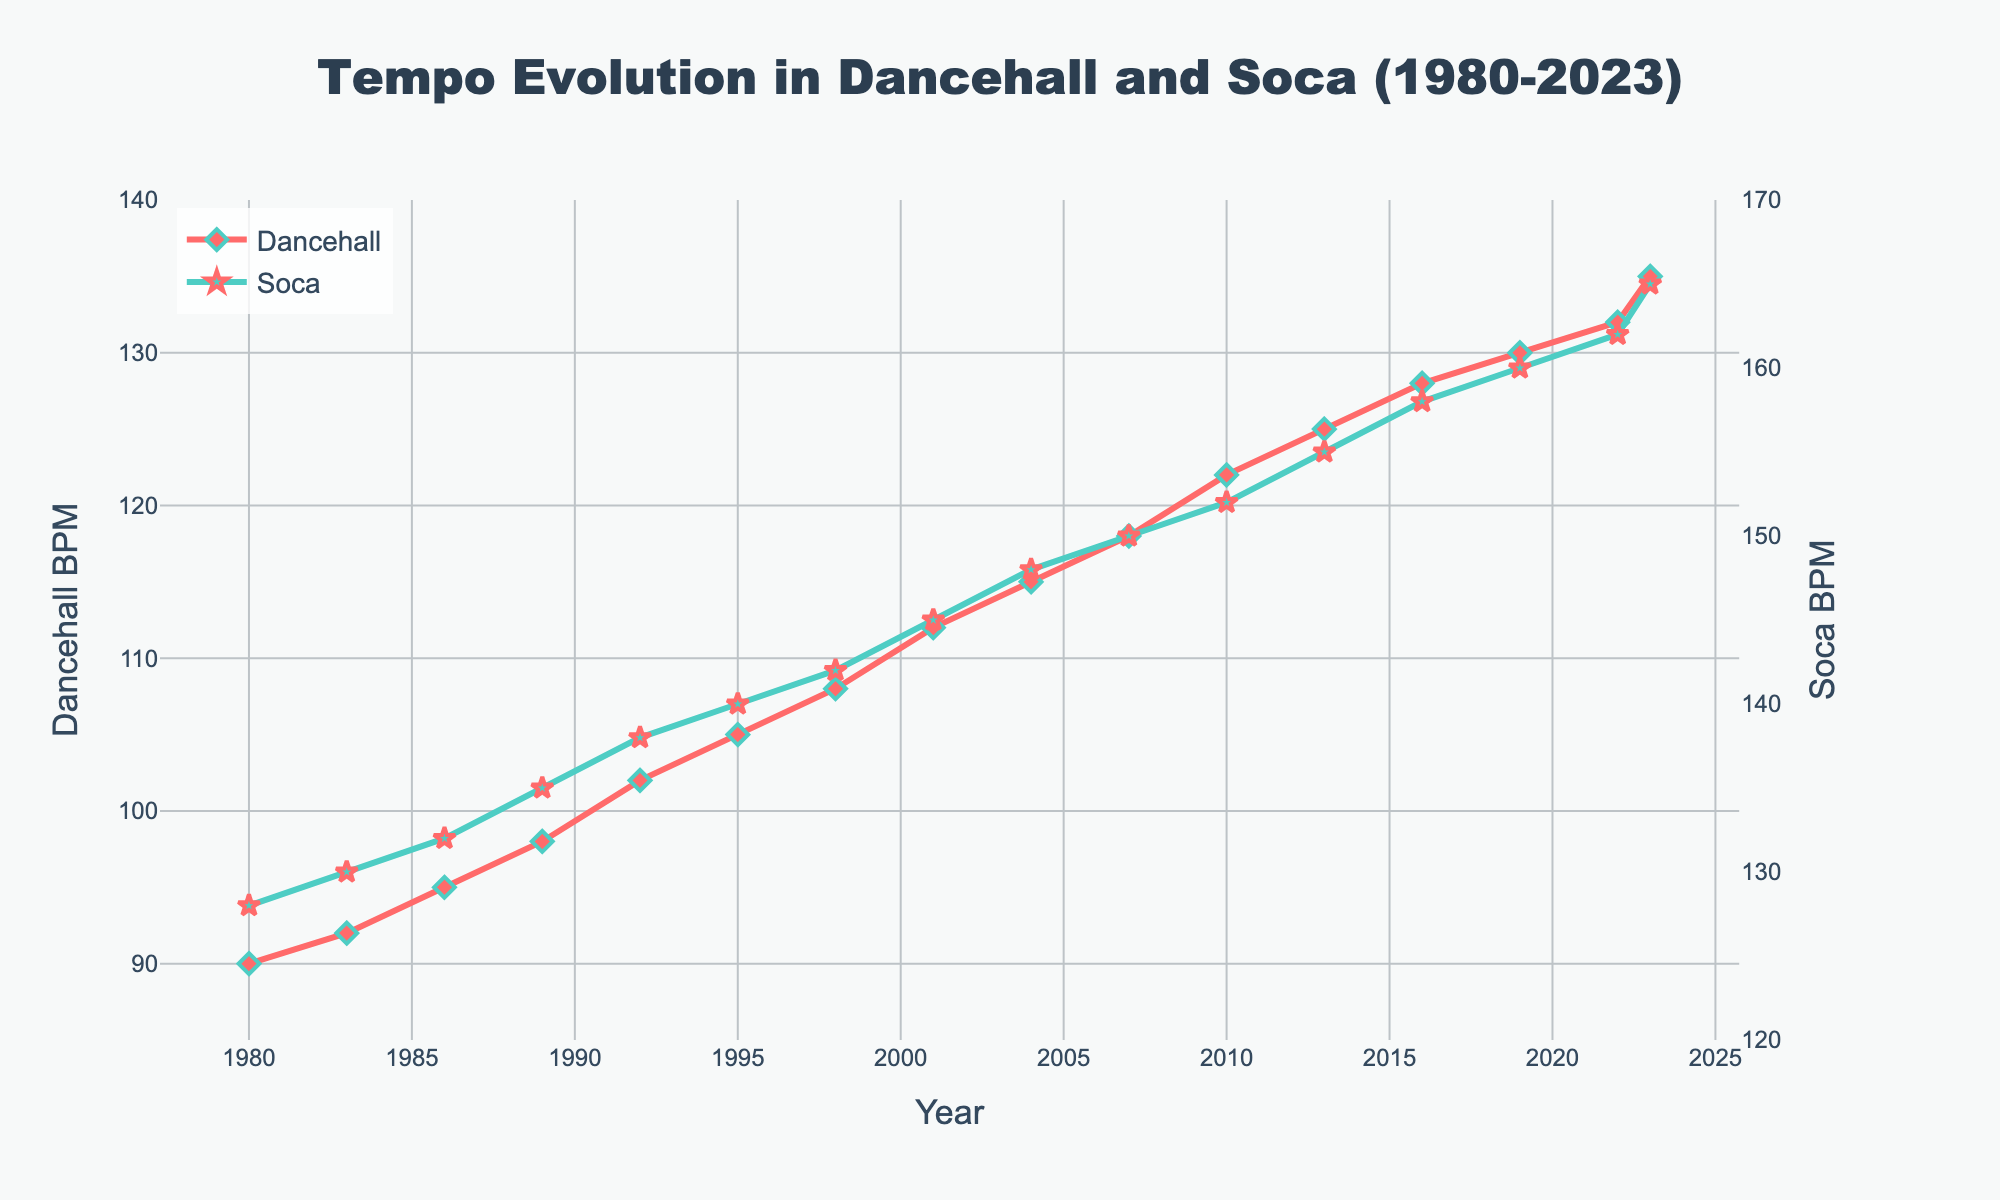Which year shows the highest BPM for Dancehall tracks? According to the line representing Dancehall BPM, the highest point is at 2023. Therefore, the highest BPM occurs in 2023.
Answer: 2023 How has the tempo for Soca music changed from 1980 to 2023? From the figure, the Soca BPM in 1980 is 128 and increases to 165 in 2023. Over this period, the tempo of Soca music has increased steadily.
Answer: Increased Compare the BPM for Dancehall and Soca in 2019. Which one is higher, and by how much? In 2019, the BPM for Dancehall is 130, and for Soca, it is 160. The difference is 160 - 130 = 30 BPM, with Soca having the higher BPM.
Answer: Soca by 30 BPM What is the average BPM of Dancehall tracks between 2004 and 2013? Considering the Dancehall BPMs in 2004, 2007, 2010, and 2013 (115, 118, 122, and 125), the sum is 115 + 118 + 122 + 125 = 480. Dividing by the 4 years, the average BPM is 480 / 4 = 120.
Answer: 120 BPM Describe the trend in Dancehall BPM from 2010 to 2023. The figure shows a steady increase in Dancehall BPM from 122 in 2010 to 135 in 2023, indicating a consistent upward trend in tempo.
Answer: Steady increase How does the Soca BPM change between 2016 and 2022? Between 2016 and 2022, the Soca BPM increases from 158 to 162, showing a slight upward trend.
Answer: Slight increase By how much did the Dancehall BPM increase from 1989 to 2001? In 1989, the Dancehall BPM is 98, and in 2001, it is 112. The increase is 112 - 98 = 14 BPM.
Answer: 14 BPM Which year shows the closest BPM values for both Dancehall and Soca tracks? By examining the figure, the year 2022 shows the closest BPM values, with Dancehall BPM at 132 and Soca BPM at 162, having a difference of 30 BPM, which is the smallest visual difference.
Answer: 2022 What is the overall difference in Soca BPM from the start (1980) to the end (2023) of the given time frame? Initial Soca BPM in 1980 is 128, and in 2023 it is 165. The overall difference is 165 - 128 = 37 BPM.
Answer: 37 BPM 